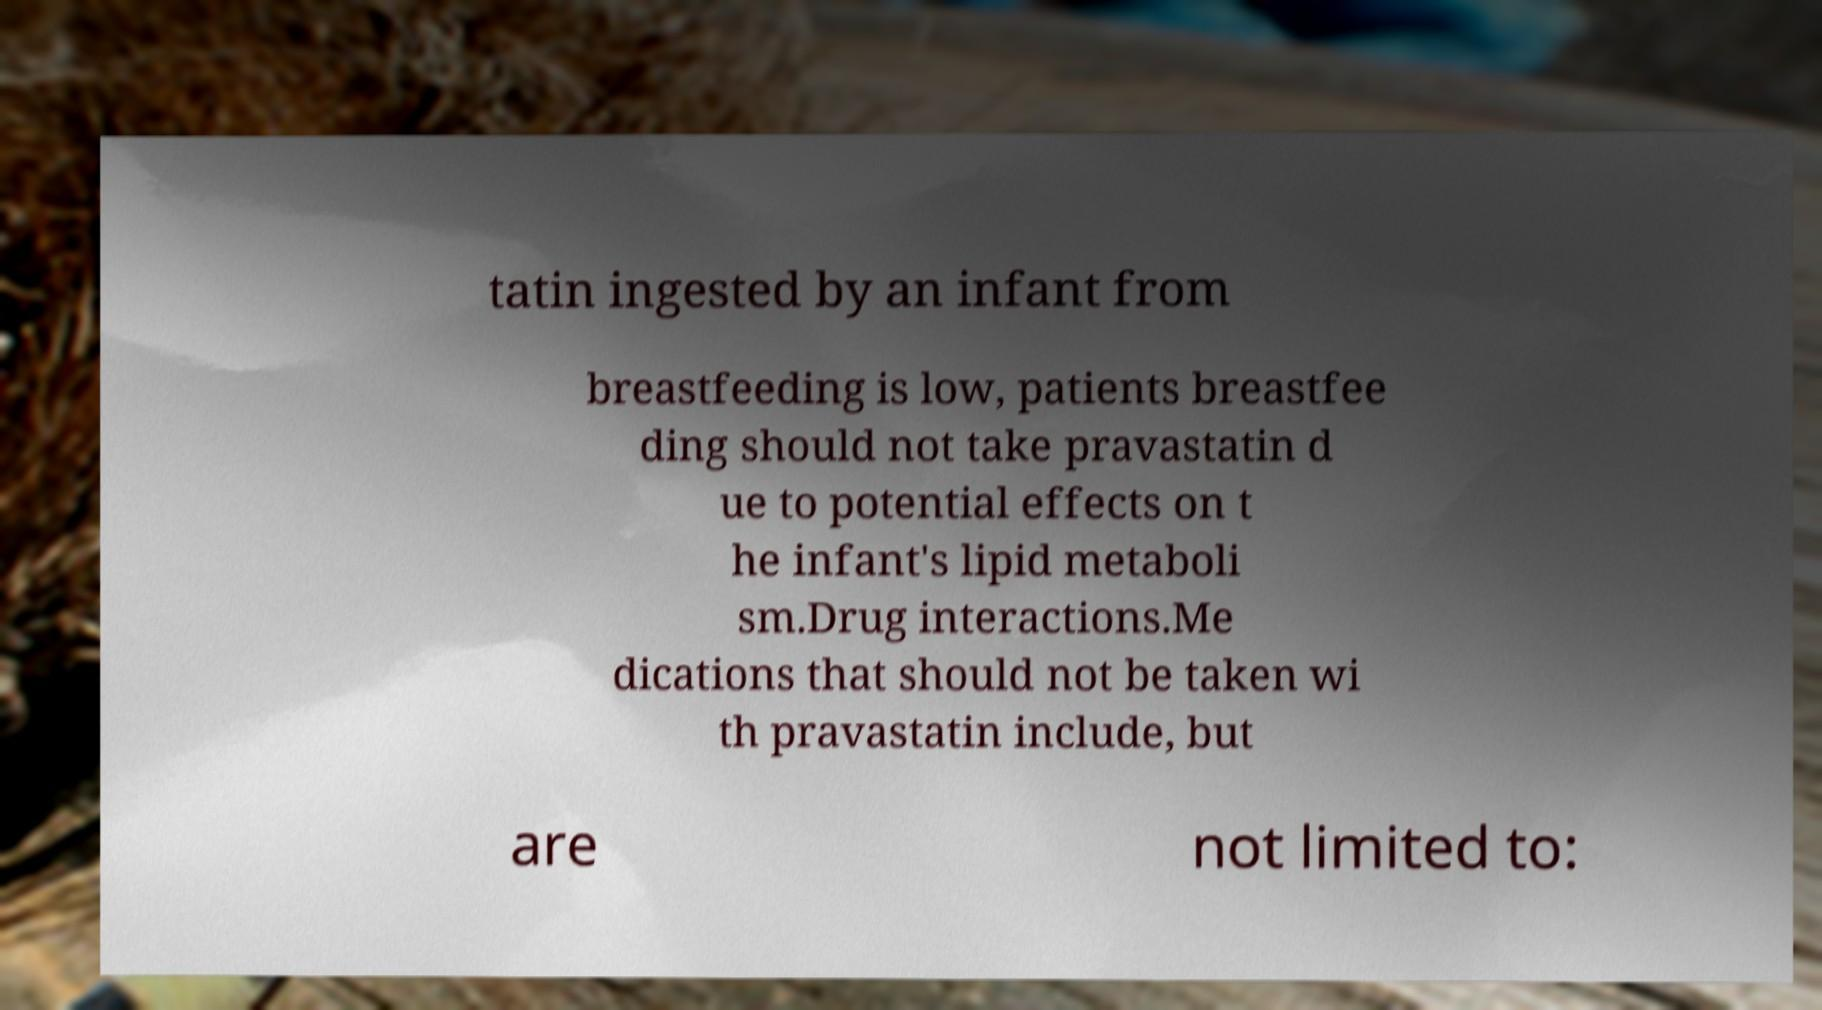Can you accurately transcribe the text from the provided image for me? tatin ingested by an infant from breastfeeding is low, patients breastfee ding should not take pravastatin d ue to potential effects on t he infant's lipid metaboli sm.Drug interactions.Me dications that should not be taken wi th pravastatin include, but are not limited to: 